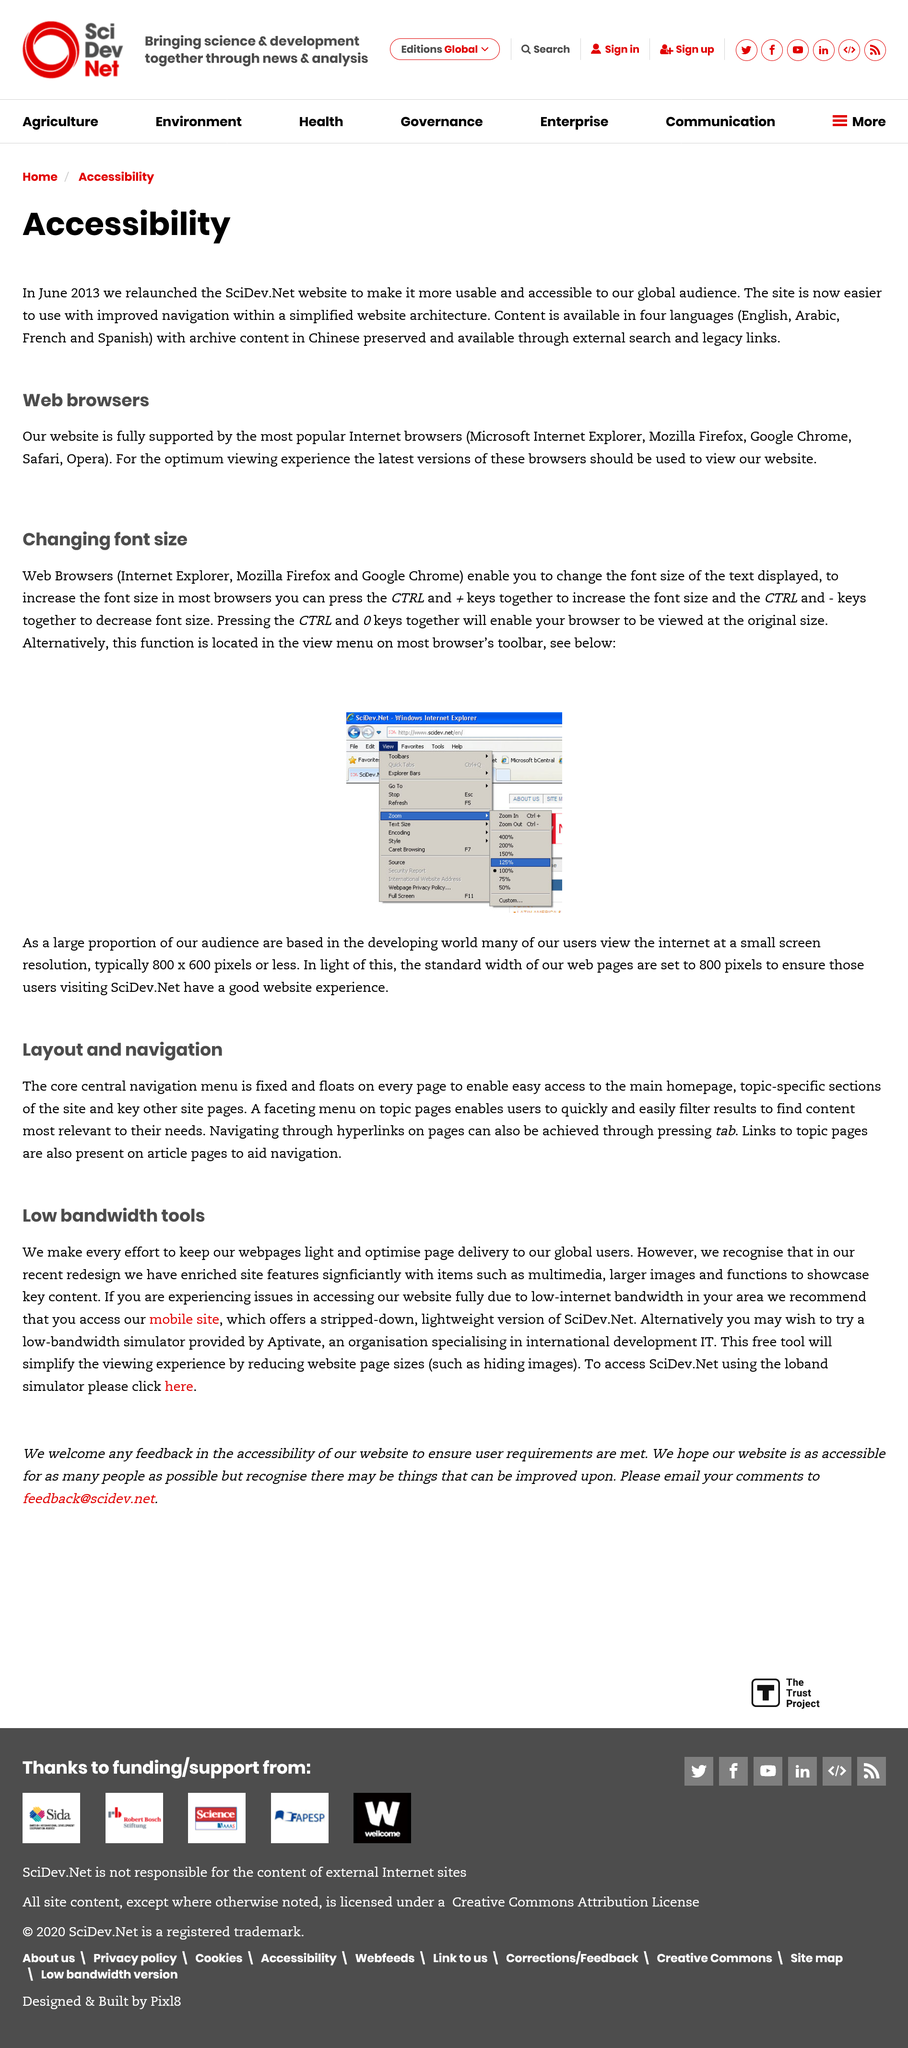Draw attention to some important aspects in this diagram. It is recommended that individuals use the latest version of web browsers in order to achieve the optimal viewing experience. Yes, the June 2013 relaunch of the website ensures full support from the most popular internet browsers. Content is available in the languages of English, Arabic, French, and Spanish. 